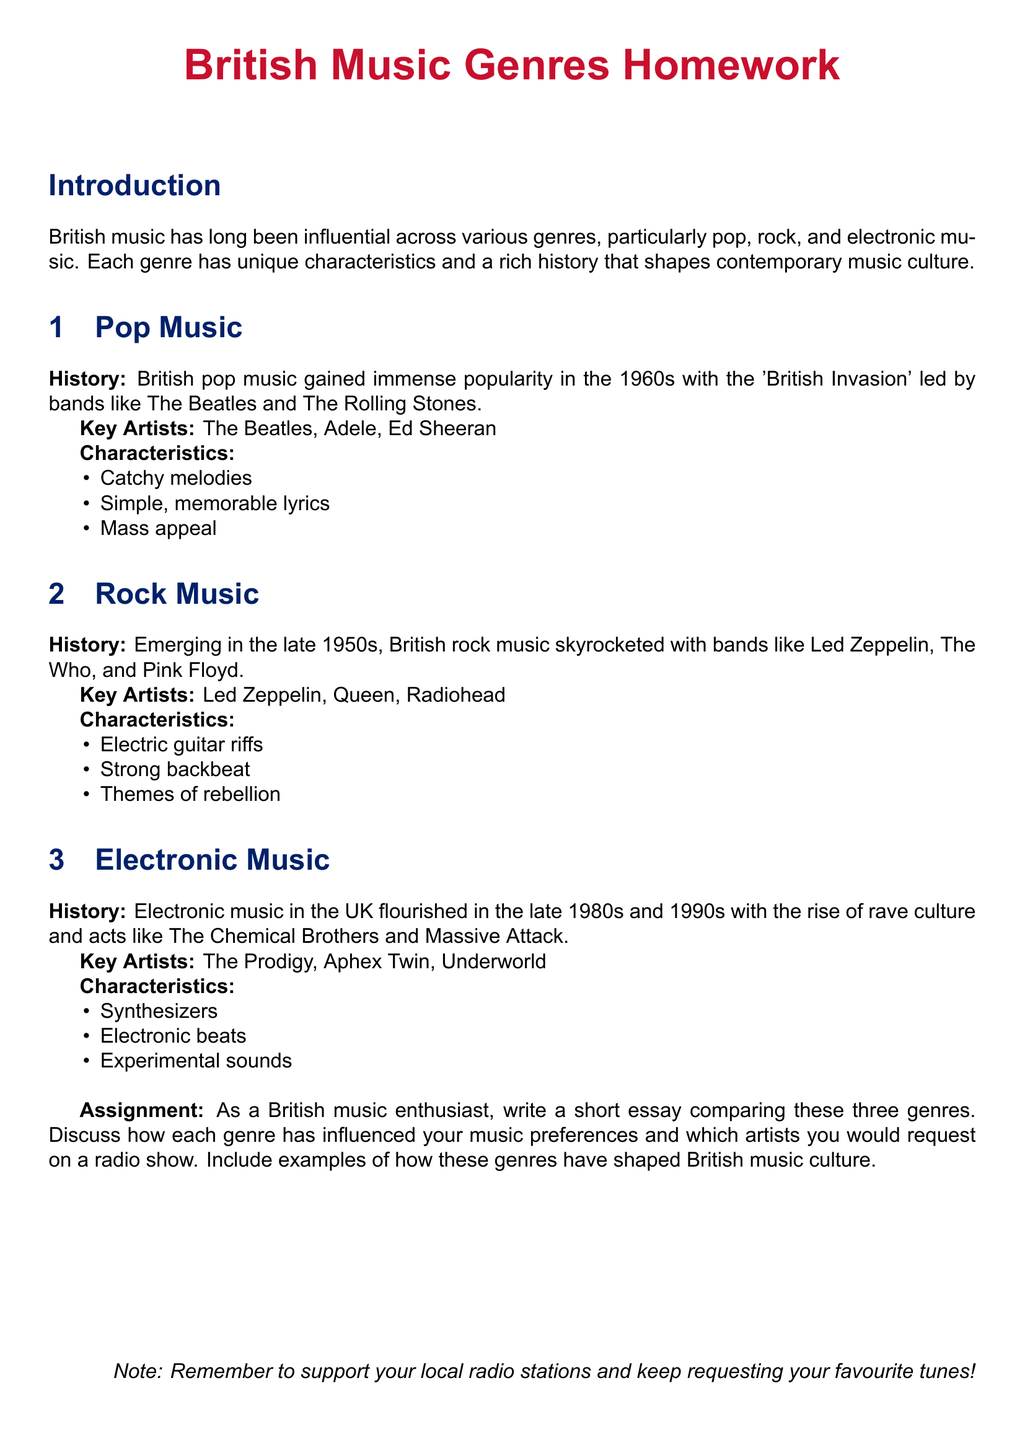What decade did British pop music gain immense popularity? The document states that British pop music gained immense popularity in the 1960s.
Answer: 1960s Name one key artist from rock music in the UK. The document lists Led Zeppelin, Queen, and Radiohead as key artists in rock music.
Answer: Led Zeppelin What are the characteristics of pop music? The characteristics of pop music include catchy melodies, simple, memorable lyrics, and mass appeal.
Answer: Catchy melodies, simple lyrics, mass appeal Which genre is associated with synthesizers? The document mentions that electronic music is characterized by synthesizers.
Answer: Electronic music What was a significant cultural event for electronic music in the UK? The rise of rave culture in the late 1980s and 1990s is noted as significant for electronic music.
Answer: Rave culture How do the themes of rock music differ from pop music? Themes of rock music include rebellion, while pop music focuses on catchy melodies and mass appeal.
Answer: Rebellion List one British pop music artist mentioned in the document. The document mentions The Beatles, Adele, and Ed Sheeran as artists in pop music.
Answer: The Beatles What is the assignment task in this document? The assignment asks to write a short essay comparing the three genres and discussing their influence on music preferences.
Answer: Write a short essay comparing genres 